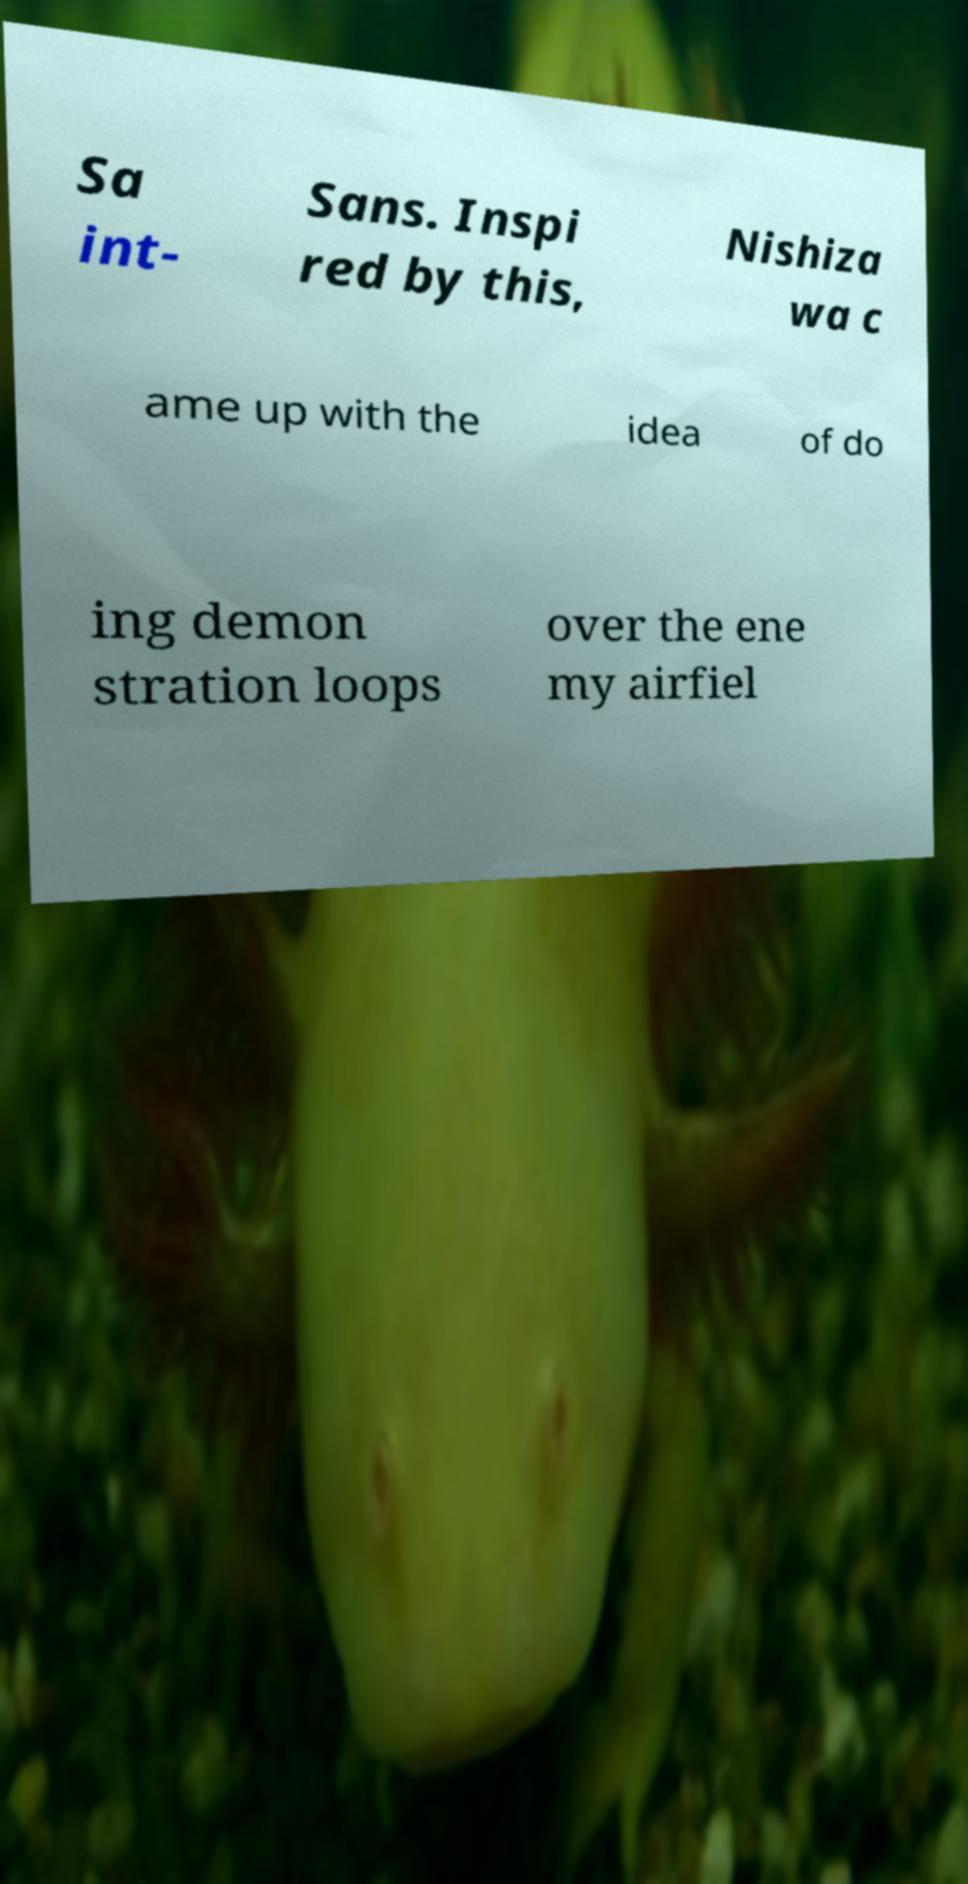Can you accurately transcribe the text from the provided image for me? Sa int- Sans. Inspi red by this, Nishiza wa c ame up with the idea of do ing demon stration loops over the ene my airfiel 